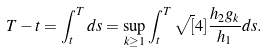Convert formula to latex. <formula><loc_0><loc_0><loc_500><loc_500>T - t = \int _ { t } ^ { T } d s = \sup _ { k \geq 1 } \int _ { t } ^ { T } \sqrt { [ } 4 ] { \frac { h _ { 2 } g _ { k } } { h _ { 1 } } } d s .</formula> 